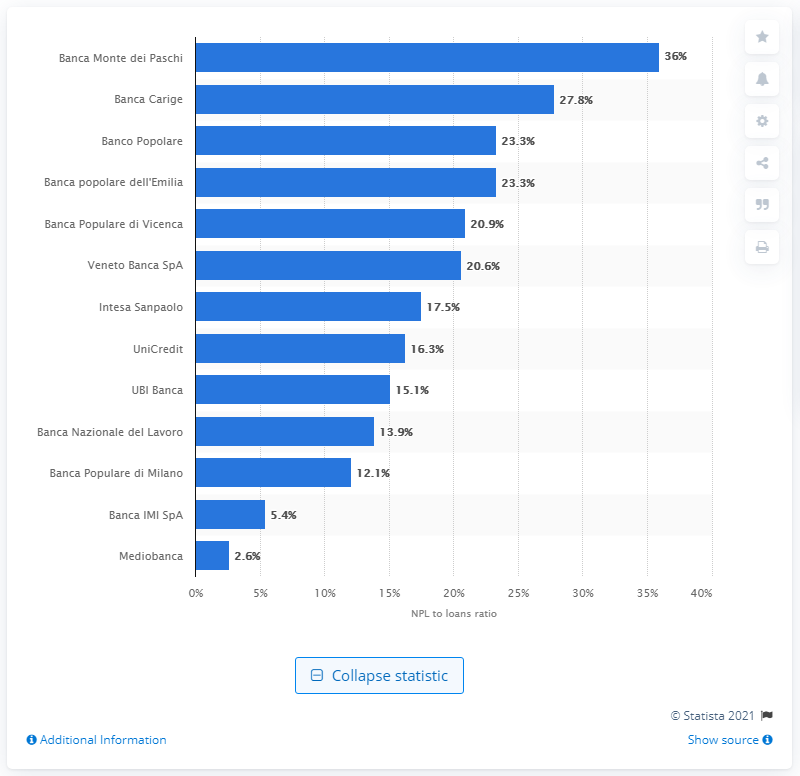Indicate a few pertinent items in this graphic. The NPL to loan ratio of Banca Carige was 27.8%. Banca Monte dei Paschi di Siena was ranked as the first bank in Italy that was in the most difficult situation. 